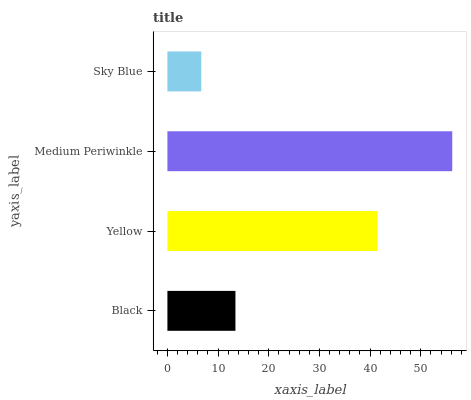Is Sky Blue the minimum?
Answer yes or no. Yes. Is Medium Periwinkle the maximum?
Answer yes or no. Yes. Is Yellow the minimum?
Answer yes or no. No. Is Yellow the maximum?
Answer yes or no. No. Is Yellow greater than Black?
Answer yes or no. Yes. Is Black less than Yellow?
Answer yes or no. Yes. Is Black greater than Yellow?
Answer yes or no. No. Is Yellow less than Black?
Answer yes or no. No. Is Yellow the high median?
Answer yes or no. Yes. Is Black the low median?
Answer yes or no. Yes. Is Medium Periwinkle the high median?
Answer yes or no. No. Is Medium Periwinkle the low median?
Answer yes or no. No. 